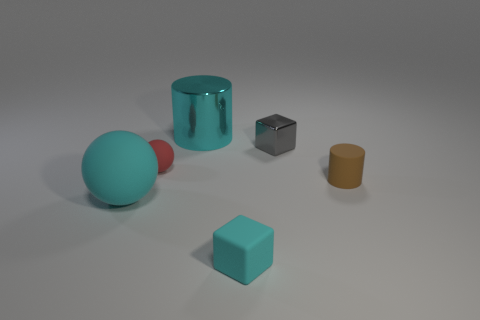There is a small cube in front of the matte cylinder; what material is it?
Provide a succinct answer. Rubber. Are there the same number of tiny gray metallic blocks that are in front of the tiny cyan thing and tiny yellow metallic things?
Keep it short and to the point. Yes. How many tiny rubber objects are the same color as the metallic cylinder?
Your answer should be very brief. 1. There is another large thing that is the same shape as the red thing; what is its color?
Offer a very short reply. Cyan. Is the size of the gray shiny thing the same as the brown cylinder?
Your response must be concise. Yes. Is the number of brown matte cylinders to the left of the tiny gray metal block the same as the number of small red rubber objects on the right side of the large shiny object?
Give a very brief answer. Yes. Are any large green metallic spheres visible?
Your answer should be very brief. No. There is a cyan object that is the same shape as the gray thing; what is its size?
Provide a succinct answer. Small. There is a ball in front of the small brown object; what size is it?
Give a very brief answer. Large. Is the number of small cyan cubes behind the large matte ball greater than the number of small gray things?
Provide a succinct answer. No. 